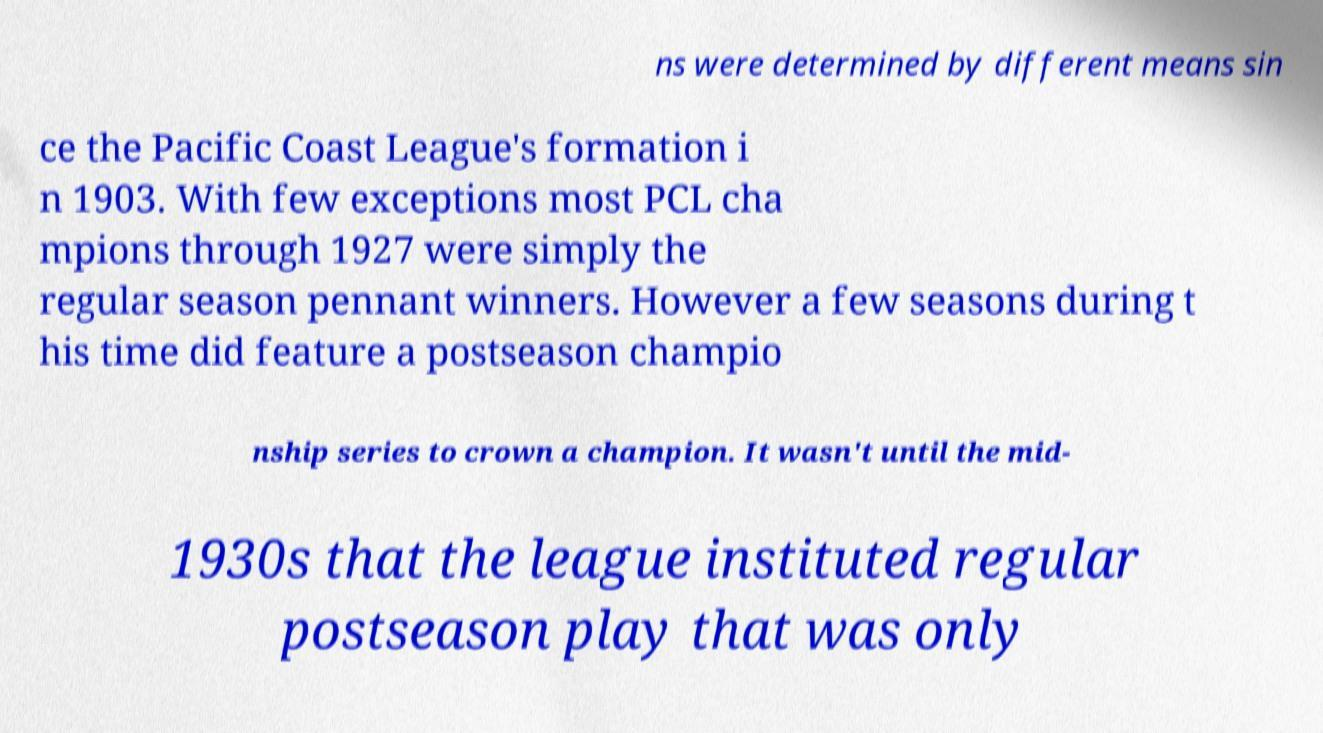Could you extract and type out the text from this image? ns were determined by different means sin ce the Pacific Coast League's formation i n 1903. With few exceptions most PCL cha mpions through 1927 were simply the regular season pennant winners. However a few seasons during t his time did feature a postseason champio nship series to crown a champion. It wasn't until the mid- 1930s that the league instituted regular postseason play that was only 